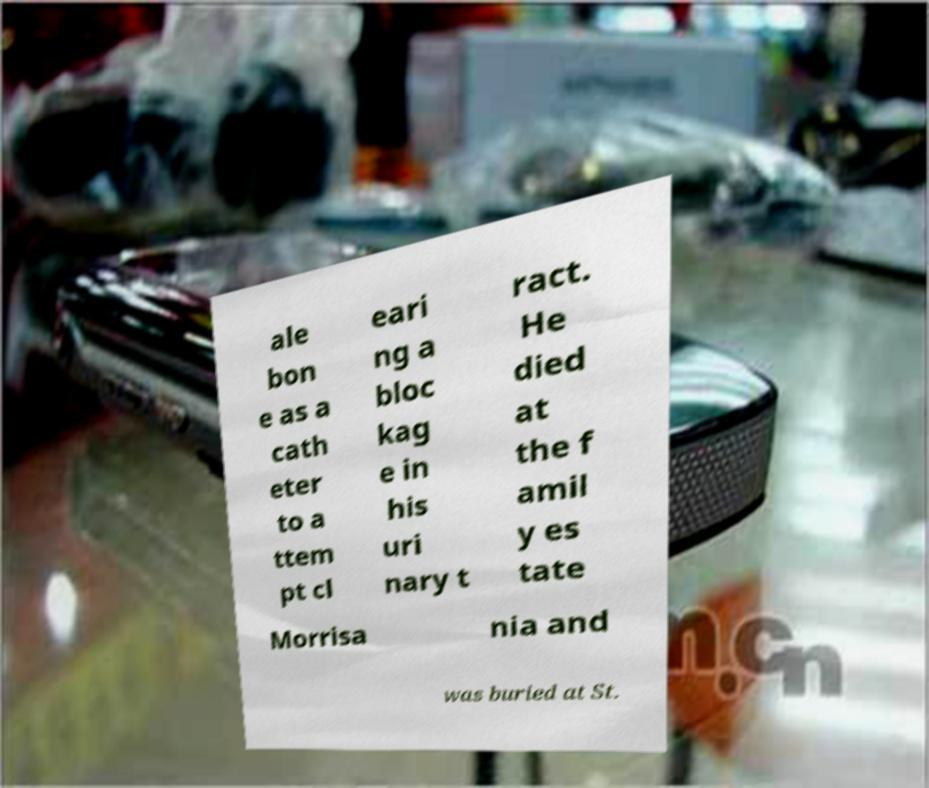There's text embedded in this image that I need extracted. Can you transcribe it verbatim? ale bon e as a cath eter to a ttem pt cl eari ng a bloc kag e in his uri nary t ract. He died at the f amil y es tate Morrisa nia and was buried at St. 